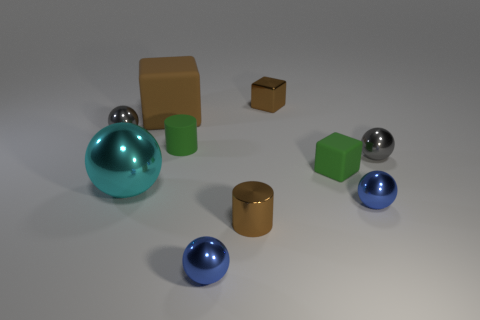Subtract all small green rubber cubes. How many cubes are left? 2 Subtract all purple cylinders. How many brown cubes are left? 2 Subtract all blue spheres. How many spheres are left? 3 Subtract 1 balls. How many balls are left? 4 Subtract all purple blocks. Subtract all blue cylinders. How many blocks are left? 3 Subtract 1 gray balls. How many objects are left? 9 Subtract all blocks. How many objects are left? 7 Subtract all cyan metallic objects. Subtract all tiny blue balls. How many objects are left? 7 Add 5 tiny matte blocks. How many tiny matte blocks are left? 6 Add 8 tiny blue balls. How many tiny blue balls exist? 10 